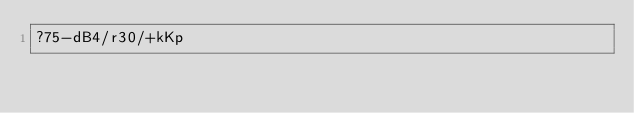Convert code to text. <code><loc_0><loc_0><loc_500><loc_500><_dc_>?75-dB4/r30/+kKp</code> 